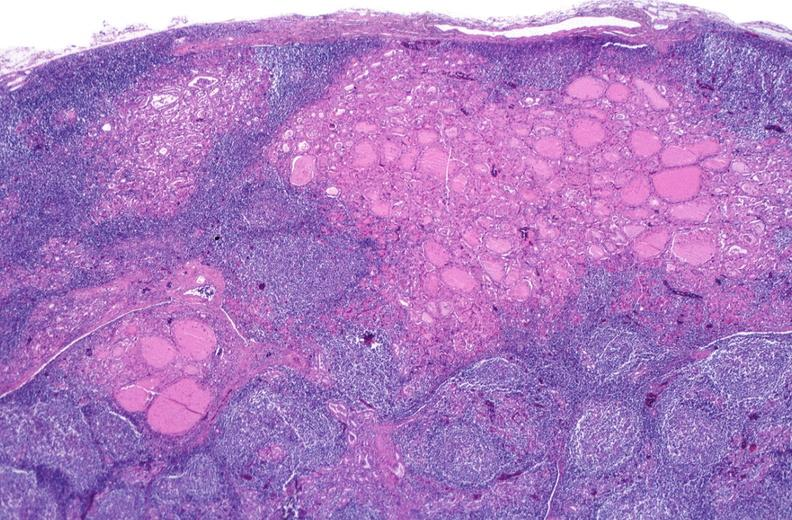where is this part in the figure?
Answer the question using a single word or phrase. Endocrine system 